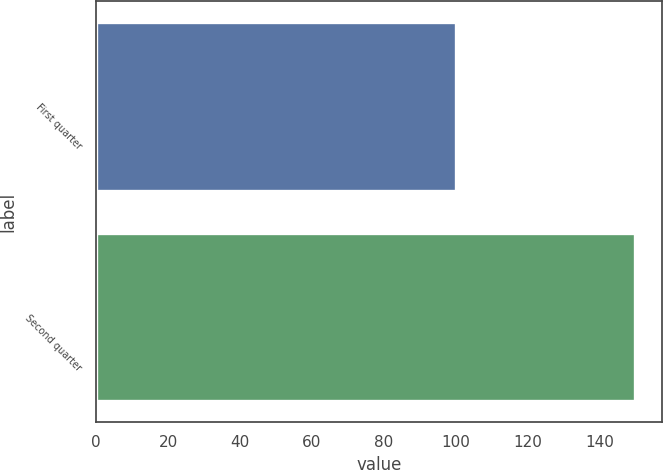<chart> <loc_0><loc_0><loc_500><loc_500><bar_chart><fcel>First quarter<fcel>Second quarter<nl><fcel>100<fcel>150<nl></chart> 